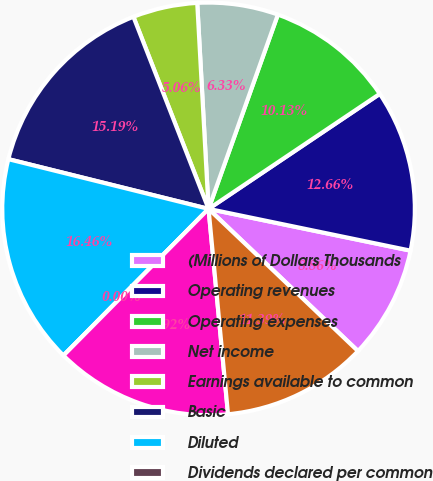Convert chart to OTSL. <chart><loc_0><loc_0><loc_500><loc_500><pie_chart><fcel>(Millions of Dollars Thousands<fcel>Operating revenues<fcel>Operating expenses<fcel>Net income<fcel>Earnings available to common<fcel>Basic<fcel>Diluted<fcel>Dividends declared per common<fcel>Total assets<fcel>Long-term debt ^(a)<nl><fcel>8.86%<fcel>12.66%<fcel>10.13%<fcel>6.33%<fcel>5.06%<fcel>15.19%<fcel>16.46%<fcel>0.0%<fcel>13.92%<fcel>11.39%<nl></chart> 